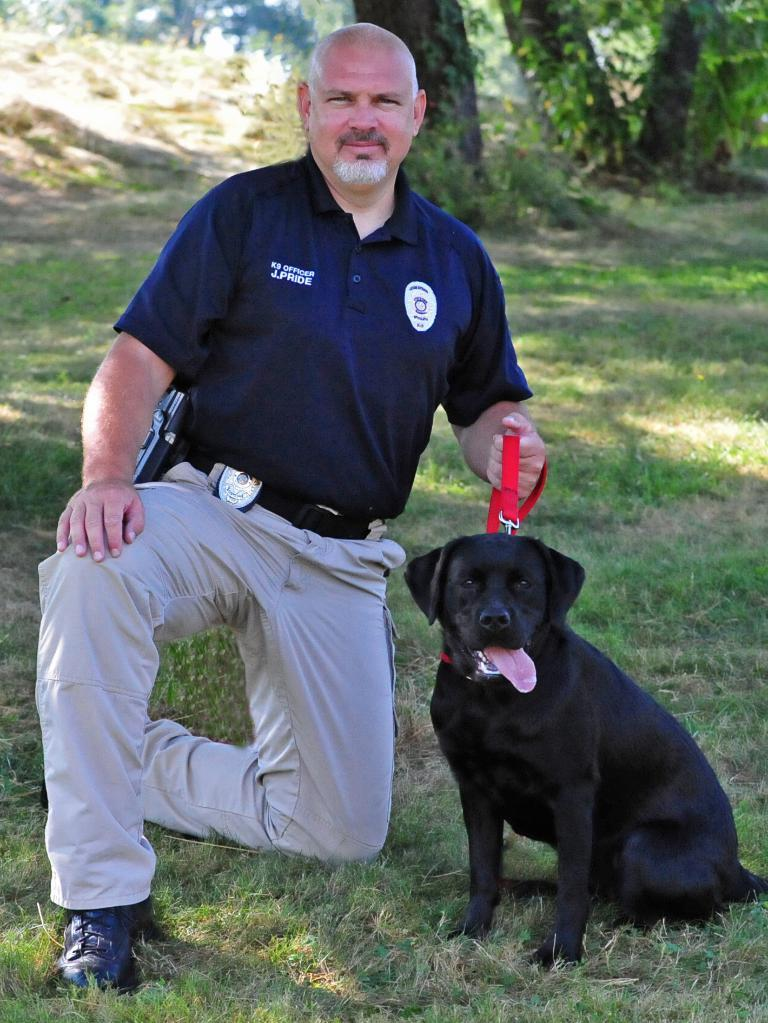What is the setting of the image? The image shows an outside view. Can you describe the person in the image? There is a person in the image, and they are wearing clothes. What is the person doing in the image? The person is holding a dog with a leash. What type of surface is visible on the ground in the image? There is grass on the ground in the image. Where is the faucet located in the image? There is no faucet present in the image. Can you tell me how many family members are visible in the image? The image only shows one person, so it is not possible to determine the number of family members. 